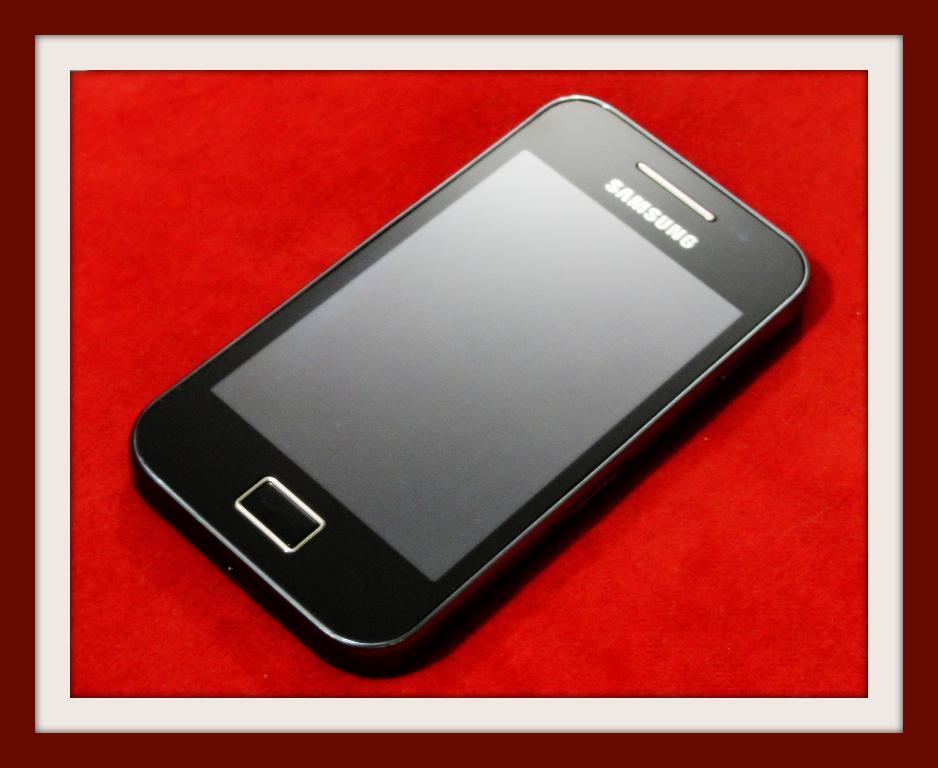Provide a one-sentence caption for the provided image. a black samsung phone with the screen off and a rectangular button at the bottom. 